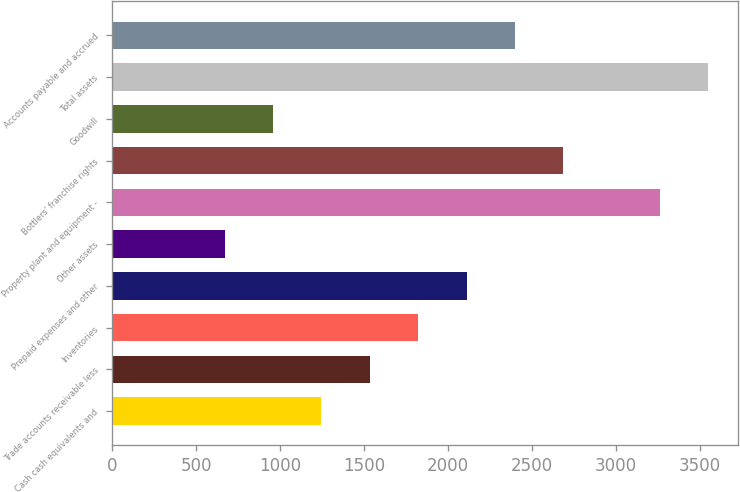Convert chart to OTSL. <chart><loc_0><loc_0><loc_500><loc_500><bar_chart><fcel>Cash cash equivalents and<fcel>Trade accounts receivable less<fcel>Inventories<fcel>Prepaid expenses and other<fcel>Other assets<fcel>Property plant and equipment -<fcel>Bottlers' franchise rights<fcel>Goodwill<fcel>Total assets<fcel>Accounts payable and accrued<nl><fcel>1246.2<fcel>1534<fcel>1821.8<fcel>2109.6<fcel>670.6<fcel>3260.8<fcel>2685.2<fcel>958.4<fcel>3548.6<fcel>2397.4<nl></chart> 